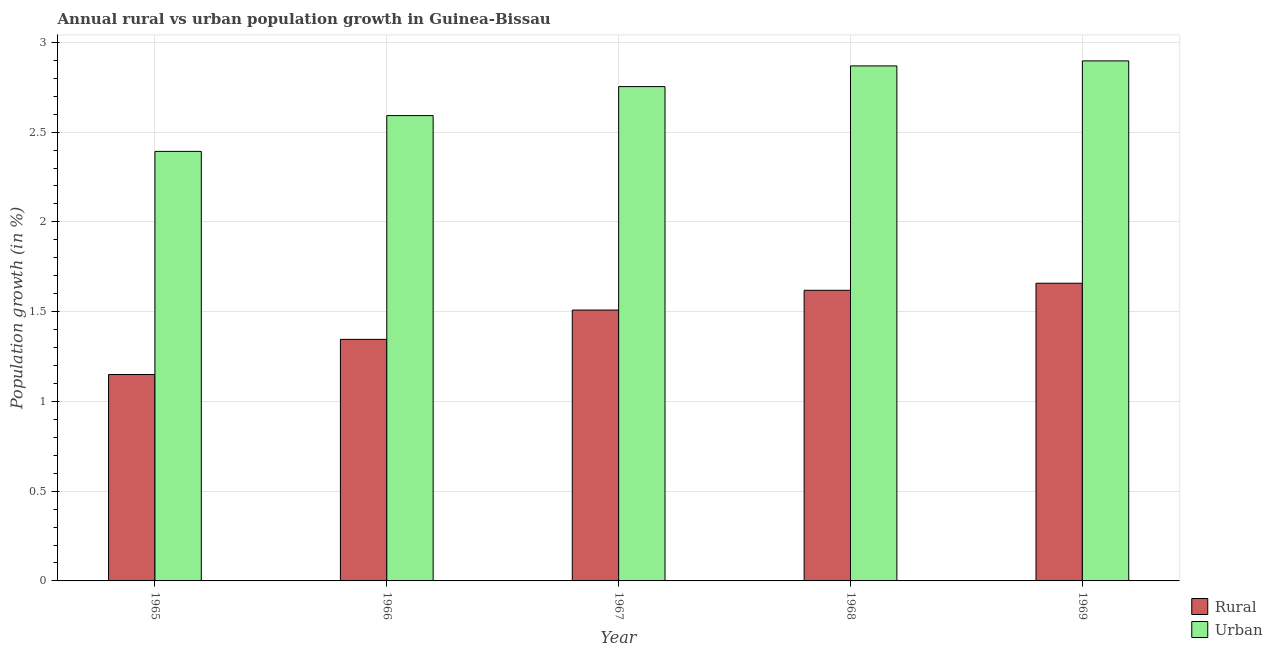Are the number of bars per tick equal to the number of legend labels?
Provide a succinct answer. Yes. Are the number of bars on each tick of the X-axis equal?
Keep it short and to the point. Yes. How many bars are there on the 1st tick from the left?
Ensure brevity in your answer.  2. What is the label of the 2nd group of bars from the left?
Provide a succinct answer. 1966. In how many cases, is the number of bars for a given year not equal to the number of legend labels?
Offer a very short reply. 0. What is the rural population growth in 1967?
Offer a terse response. 1.51. Across all years, what is the maximum urban population growth?
Your response must be concise. 2.9. Across all years, what is the minimum rural population growth?
Your answer should be very brief. 1.15. In which year was the rural population growth maximum?
Give a very brief answer. 1969. In which year was the rural population growth minimum?
Offer a terse response. 1965. What is the total rural population growth in the graph?
Your answer should be compact. 7.28. What is the difference between the urban population growth in 1965 and that in 1969?
Your answer should be very brief. -0.5. What is the difference between the urban population growth in 1966 and the rural population growth in 1967?
Make the answer very short. -0.16. What is the average urban population growth per year?
Make the answer very short. 2.7. In the year 1967, what is the difference between the urban population growth and rural population growth?
Provide a short and direct response. 0. What is the ratio of the urban population growth in 1966 to that in 1969?
Your response must be concise. 0.89. Is the rural population growth in 1966 less than that in 1967?
Provide a succinct answer. Yes. Is the difference between the urban population growth in 1965 and 1968 greater than the difference between the rural population growth in 1965 and 1968?
Offer a terse response. No. What is the difference between the highest and the second highest urban population growth?
Your answer should be compact. 0.03. What is the difference between the highest and the lowest rural population growth?
Your response must be concise. 0.51. In how many years, is the urban population growth greater than the average urban population growth taken over all years?
Ensure brevity in your answer.  3. Is the sum of the rural population growth in 1967 and 1968 greater than the maximum urban population growth across all years?
Your response must be concise. Yes. What does the 1st bar from the left in 1967 represents?
Make the answer very short. Rural. What does the 1st bar from the right in 1967 represents?
Keep it short and to the point. Urban . How many bars are there?
Your response must be concise. 10. Are the values on the major ticks of Y-axis written in scientific E-notation?
Ensure brevity in your answer.  No. Does the graph contain any zero values?
Offer a very short reply. No. Does the graph contain grids?
Your response must be concise. Yes. How many legend labels are there?
Offer a terse response. 2. What is the title of the graph?
Keep it short and to the point. Annual rural vs urban population growth in Guinea-Bissau. What is the label or title of the X-axis?
Offer a terse response. Year. What is the label or title of the Y-axis?
Offer a very short reply. Population growth (in %). What is the Population growth (in %) of Rural in 1965?
Your answer should be compact. 1.15. What is the Population growth (in %) of Urban  in 1965?
Ensure brevity in your answer.  2.39. What is the Population growth (in %) of Rural in 1966?
Offer a terse response. 1.35. What is the Population growth (in %) of Urban  in 1966?
Your answer should be compact. 2.59. What is the Population growth (in %) in Rural in 1967?
Ensure brevity in your answer.  1.51. What is the Population growth (in %) of Urban  in 1967?
Ensure brevity in your answer.  2.75. What is the Population growth (in %) of Rural in 1968?
Provide a short and direct response. 1.62. What is the Population growth (in %) of Urban  in 1968?
Keep it short and to the point. 2.87. What is the Population growth (in %) of Rural in 1969?
Give a very brief answer. 1.66. What is the Population growth (in %) in Urban  in 1969?
Provide a short and direct response. 2.9. Across all years, what is the maximum Population growth (in %) in Rural?
Keep it short and to the point. 1.66. Across all years, what is the maximum Population growth (in %) in Urban ?
Give a very brief answer. 2.9. Across all years, what is the minimum Population growth (in %) of Rural?
Your response must be concise. 1.15. Across all years, what is the minimum Population growth (in %) in Urban ?
Make the answer very short. 2.39. What is the total Population growth (in %) in Rural in the graph?
Provide a short and direct response. 7.28. What is the total Population growth (in %) of Urban  in the graph?
Your response must be concise. 13.5. What is the difference between the Population growth (in %) in Rural in 1965 and that in 1966?
Provide a short and direct response. -0.2. What is the difference between the Population growth (in %) of Urban  in 1965 and that in 1966?
Your response must be concise. -0.2. What is the difference between the Population growth (in %) in Rural in 1965 and that in 1967?
Make the answer very short. -0.36. What is the difference between the Population growth (in %) of Urban  in 1965 and that in 1967?
Your answer should be very brief. -0.36. What is the difference between the Population growth (in %) of Rural in 1965 and that in 1968?
Keep it short and to the point. -0.47. What is the difference between the Population growth (in %) in Urban  in 1965 and that in 1968?
Provide a succinct answer. -0.48. What is the difference between the Population growth (in %) of Rural in 1965 and that in 1969?
Your answer should be very brief. -0.51. What is the difference between the Population growth (in %) in Urban  in 1965 and that in 1969?
Your answer should be compact. -0.5. What is the difference between the Population growth (in %) of Rural in 1966 and that in 1967?
Keep it short and to the point. -0.16. What is the difference between the Population growth (in %) in Urban  in 1966 and that in 1967?
Your response must be concise. -0.16. What is the difference between the Population growth (in %) in Rural in 1966 and that in 1968?
Make the answer very short. -0.27. What is the difference between the Population growth (in %) in Urban  in 1966 and that in 1968?
Provide a succinct answer. -0.28. What is the difference between the Population growth (in %) in Rural in 1966 and that in 1969?
Your response must be concise. -0.31. What is the difference between the Population growth (in %) of Urban  in 1966 and that in 1969?
Give a very brief answer. -0.3. What is the difference between the Population growth (in %) in Rural in 1967 and that in 1968?
Offer a very short reply. -0.11. What is the difference between the Population growth (in %) of Urban  in 1967 and that in 1968?
Provide a short and direct response. -0.12. What is the difference between the Population growth (in %) of Rural in 1967 and that in 1969?
Provide a succinct answer. -0.15. What is the difference between the Population growth (in %) in Urban  in 1967 and that in 1969?
Your response must be concise. -0.14. What is the difference between the Population growth (in %) of Rural in 1968 and that in 1969?
Make the answer very short. -0.04. What is the difference between the Population growth (in %) in Urban  in 1968 and that in 1969?
Your answer should be very brief. -0.03. What is the difference between the Population growth (in %) in Rural in 1965 and the Population growth (in %) in Urban  in 1966?
Your answer should be compact. -1.44. What is the difference between the Population growth (in %) of Rural in 1965 and the Population growth (in %) of Urban  in 1967?
Offer a terse response. -1.6. What is the difference between the Population growth (in %) of Rural in 1965 and the Population growth (in %) of Urban  in 1968?
Ensure brevity in your answer.  -1.72. What is the difference between the Population growth (in %) in Rural in 1965 and the Population growth (in %) in Urban  in 1969?
Make the answer very short. -1.75. What is the difference between the Population growth (in %) of Rural in 1966 and the Population growth (in %) of Urban  in 1967?
Provide a short and direct response. -1.41. What is the difference between the Population growth (in %) in Rural in 1966 and the Population growth (in %) in Urban  in 1968?
Your response must be concise. -1.52. What is the difference between the Population growth (in %) of Rural in 1966 and the Population growth (in %) of Urban  in 1969?
Your answer should be very brief. -1.55. What is the difference between the Population growth (in %) in Rural in 1967 and the Population growth (in %) in Urban  in 1968?
Provide a short and direct response. -1.36. What is the difference between the Population growth (in %) in Rural in 1967 and the Population growth (in %) in Urban  in 1969?
Give a very brief answer. -1.39. What is the difference between the Population growth (in %) of Rural in 1968 and the Population growth (in %) of Urban  in 1969?
Ensure brevity in your answer.  -1.28. What is the average Population growth (in %) in Rural per year?
Give a very brief answer. 1.46. What is the average Population growth (in %) in Urban  per year?
Make the answer very short. 2.7. In the year 1965, what is the difference between the Population growth (in %) of Rural and Population growth (in %) of Urban ?
Your answer should be compact. -1.24. In the year 1966, what is the difference between the Population growth (in %) of Rural and Population growth (in %) of Urban ?
Give a very brief answer. -1.25. In the year 1967, what is the difference between the Population growth (in %) in Rural and Population growth (in %) in Urban ?
Your answer should be compact. -1.24. In the year 1968, what is the difference between the Population growth (in %) in Rural and Population growth (in %) in Urban ?
Your answer should be very brief. -1.25. In the year 1969, what is the difference between the Population growth (in %) in Rural and Population growth (in %) in Urban ?
Provide a short and direct response. -1.24. What is the ratio of the Population growth (in %) in Rural in 1965 to that in 1966?
Provide a succinct answer. 0.85. What is the ratio of the Population growth (in %) of Rural in 1965 to that in 1967?
Your answer should be compact. 0.76. What is the ratio of the Population growth (in %) in Urban  in 1965 to that in 1967?
Your response must be concise. 0.87. What is the ratio of the Population growth (in %) in Rural in 1965 to that in 1968?
Provide a succinct answer. 0.71. What is the ratio of the Population growth (in %) in Urban  in 1965 to that in 1968?
Provide a short and direct response. 0.83. What is the ratio of the Population growth (in %) of Rural in 1965 to that in 1969?
Offer a very short reply. 0.69. What is the ratio of the Population growth (in %) of Urban  in 1965 to that in 1969?
Your answer should be compact. 0.83. What is the ratio of the Population growth (in %) of Rural in 1966 to that in 1967?
Provide a succinct answer. 0.89. What is the ratio of the Population growth (in %) of Urban  in 1966 to that in 1967?
Provide a succinct answer. 0.94. What is the ratio of the Population growth (in %) in Rural in 1966 to that in 1968?
Provide a succinct answer. 0.83. What is the ratio of the Population growth (in %) in Urban  in 1966 to that in 1968?
Your answer should be compact. 0.9. What is the ratio of the Population growth (in %) of Rural in 1966 to that in 1969?
Give a very brief answer. 0.81. What is the ratio of the Population growth (in %) of Urban  in 1966 to that in 1969?
Keep it short and to the point. 0.89. What is the ratio of the Population growth (in %) in Rural in 1967 to that in 1968?
Provide a short and direct response. 0.93. What is the ratio of the Population growth (in %) of Urban  in 1967 to that in 1968?
Ensure brevity in your answer.  0.96. What is the ratio of the Population growth (in %) of Rural in 1967 to that in 1969?
Your response must be concise. 0.91. What is the ratio of the Population growth (in %) in Urban  in 1967 to that in 1969?
Make the answer very short. 0.95. What is the ratio of the Population growth (in %) of Rural in 1968 to that in 1969?
Make the answer very short. 0.98. What is the ratio of the Population growth (in %) of Urban  in 1968 to that in 1969?
Your answer should be very brief. 0.99. What is the difference between the highest and the second highest Population growth (in %) in Rural?
Offer a very short reply. 0.04. What is the difference between the highest and the second highest Population growth (in %) in Urban ?
Offer a very short reply. 0.03. What is the difference between the highest and the lowest Population growth (in %) of Rural?
Ensure brevity in your answer.  0.51. What is the difference between the highest and the lowest Population growth (in %) in Urban ?
Offer a terse response. 0.5. 